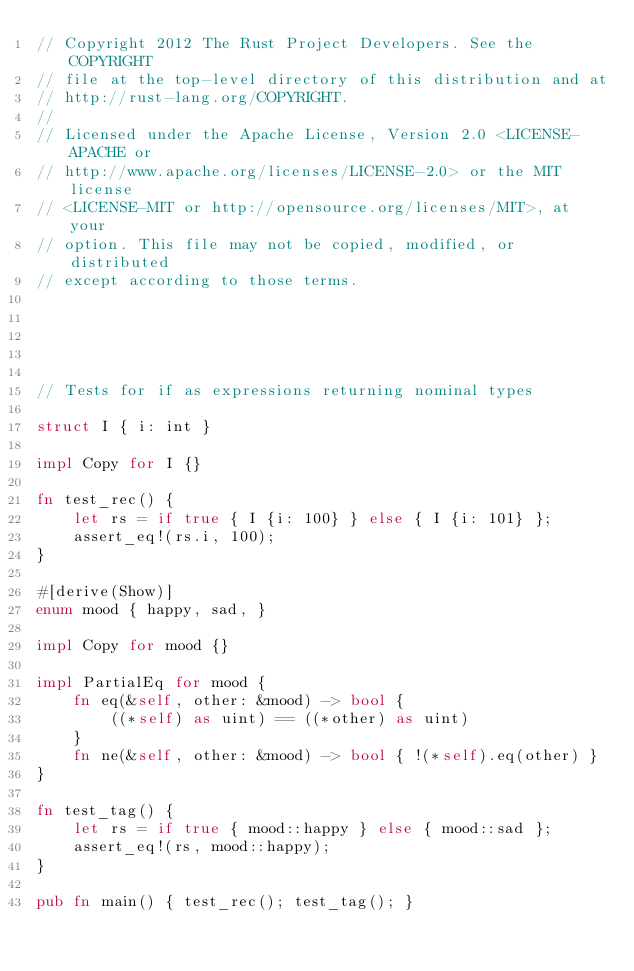Convert code to text. <code><loc_0><loc_0><loc_500><loc_500><_Rust_>// Copyright 2012 The Rust Project Developers. See the COPYRIGHT
// file at the top-level directory of this distribution and at
// http://rust-lang.org/COPYRIGHT.
//
// Licensed under the Apache License, Version 2.0 <LICENSE-APACHE or
// http://www.apache.org/licenses/LICENSE-2.0> or the MIT license
// <LICENSE-MIT or http://opensource.org/licenses/MIT>, at your
// option. This file may not be copied, modified, or distributed
// except according to those terms.





// Tests for if as expressions returning nominal types

struct I { i: int }

impl Copy for I {}

fn test_rec() {
    let rs = if true { I {i: 100} } else { I {i: 101} };
    assert_eq!(rs.i, 100);
}

#[derive(Show)]
enum mood { happy, sad, }

impl Copy for mood {}

impl PartialEq for mood {
    fn eq(&self, other: &mood) -> bool {
        ((*self) as uint) == ((*other) as uint)
    }
    fn ne(&self, other: &mood) -> bool { !(*self).eq(other) }
}

fn test_tag() {
    let rs = if true { mood::happy } else { mood::sad };
    assert_eq!(rs, mood::happy);
}

pub fn main() { test_rec(); test_tag(); }
</code> 